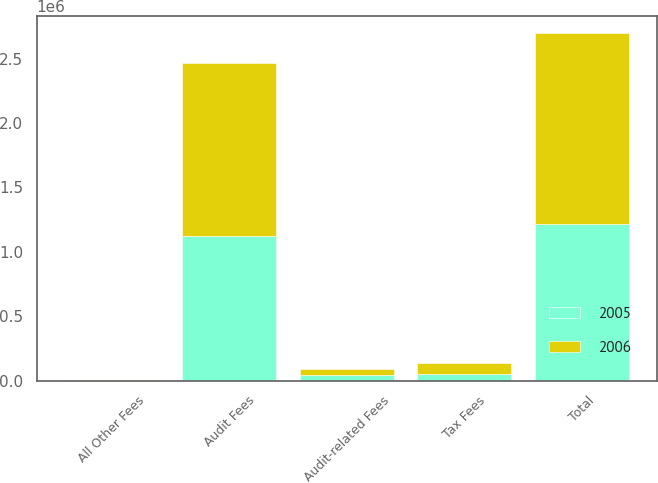<chart> <loc_0><loc_0><loc_500><loc_500><stacked_bar_chart><ecel><fcel>Audit Fees<fcel>Audit-related Fees<fcel>Tax Fees<fcel>All Other Fees<fcel>Total<nl><fcel>2006<fcel>1.3475e+06<fcel>45850<fcel>85000<fcel>1235<fcel>1.47958e+06<nl><fcel>2005<fcel>1.12008e+06<fcel>43300<fcel>53500<fcel>1500<fcel>1.21838e+06<nl></chart> 